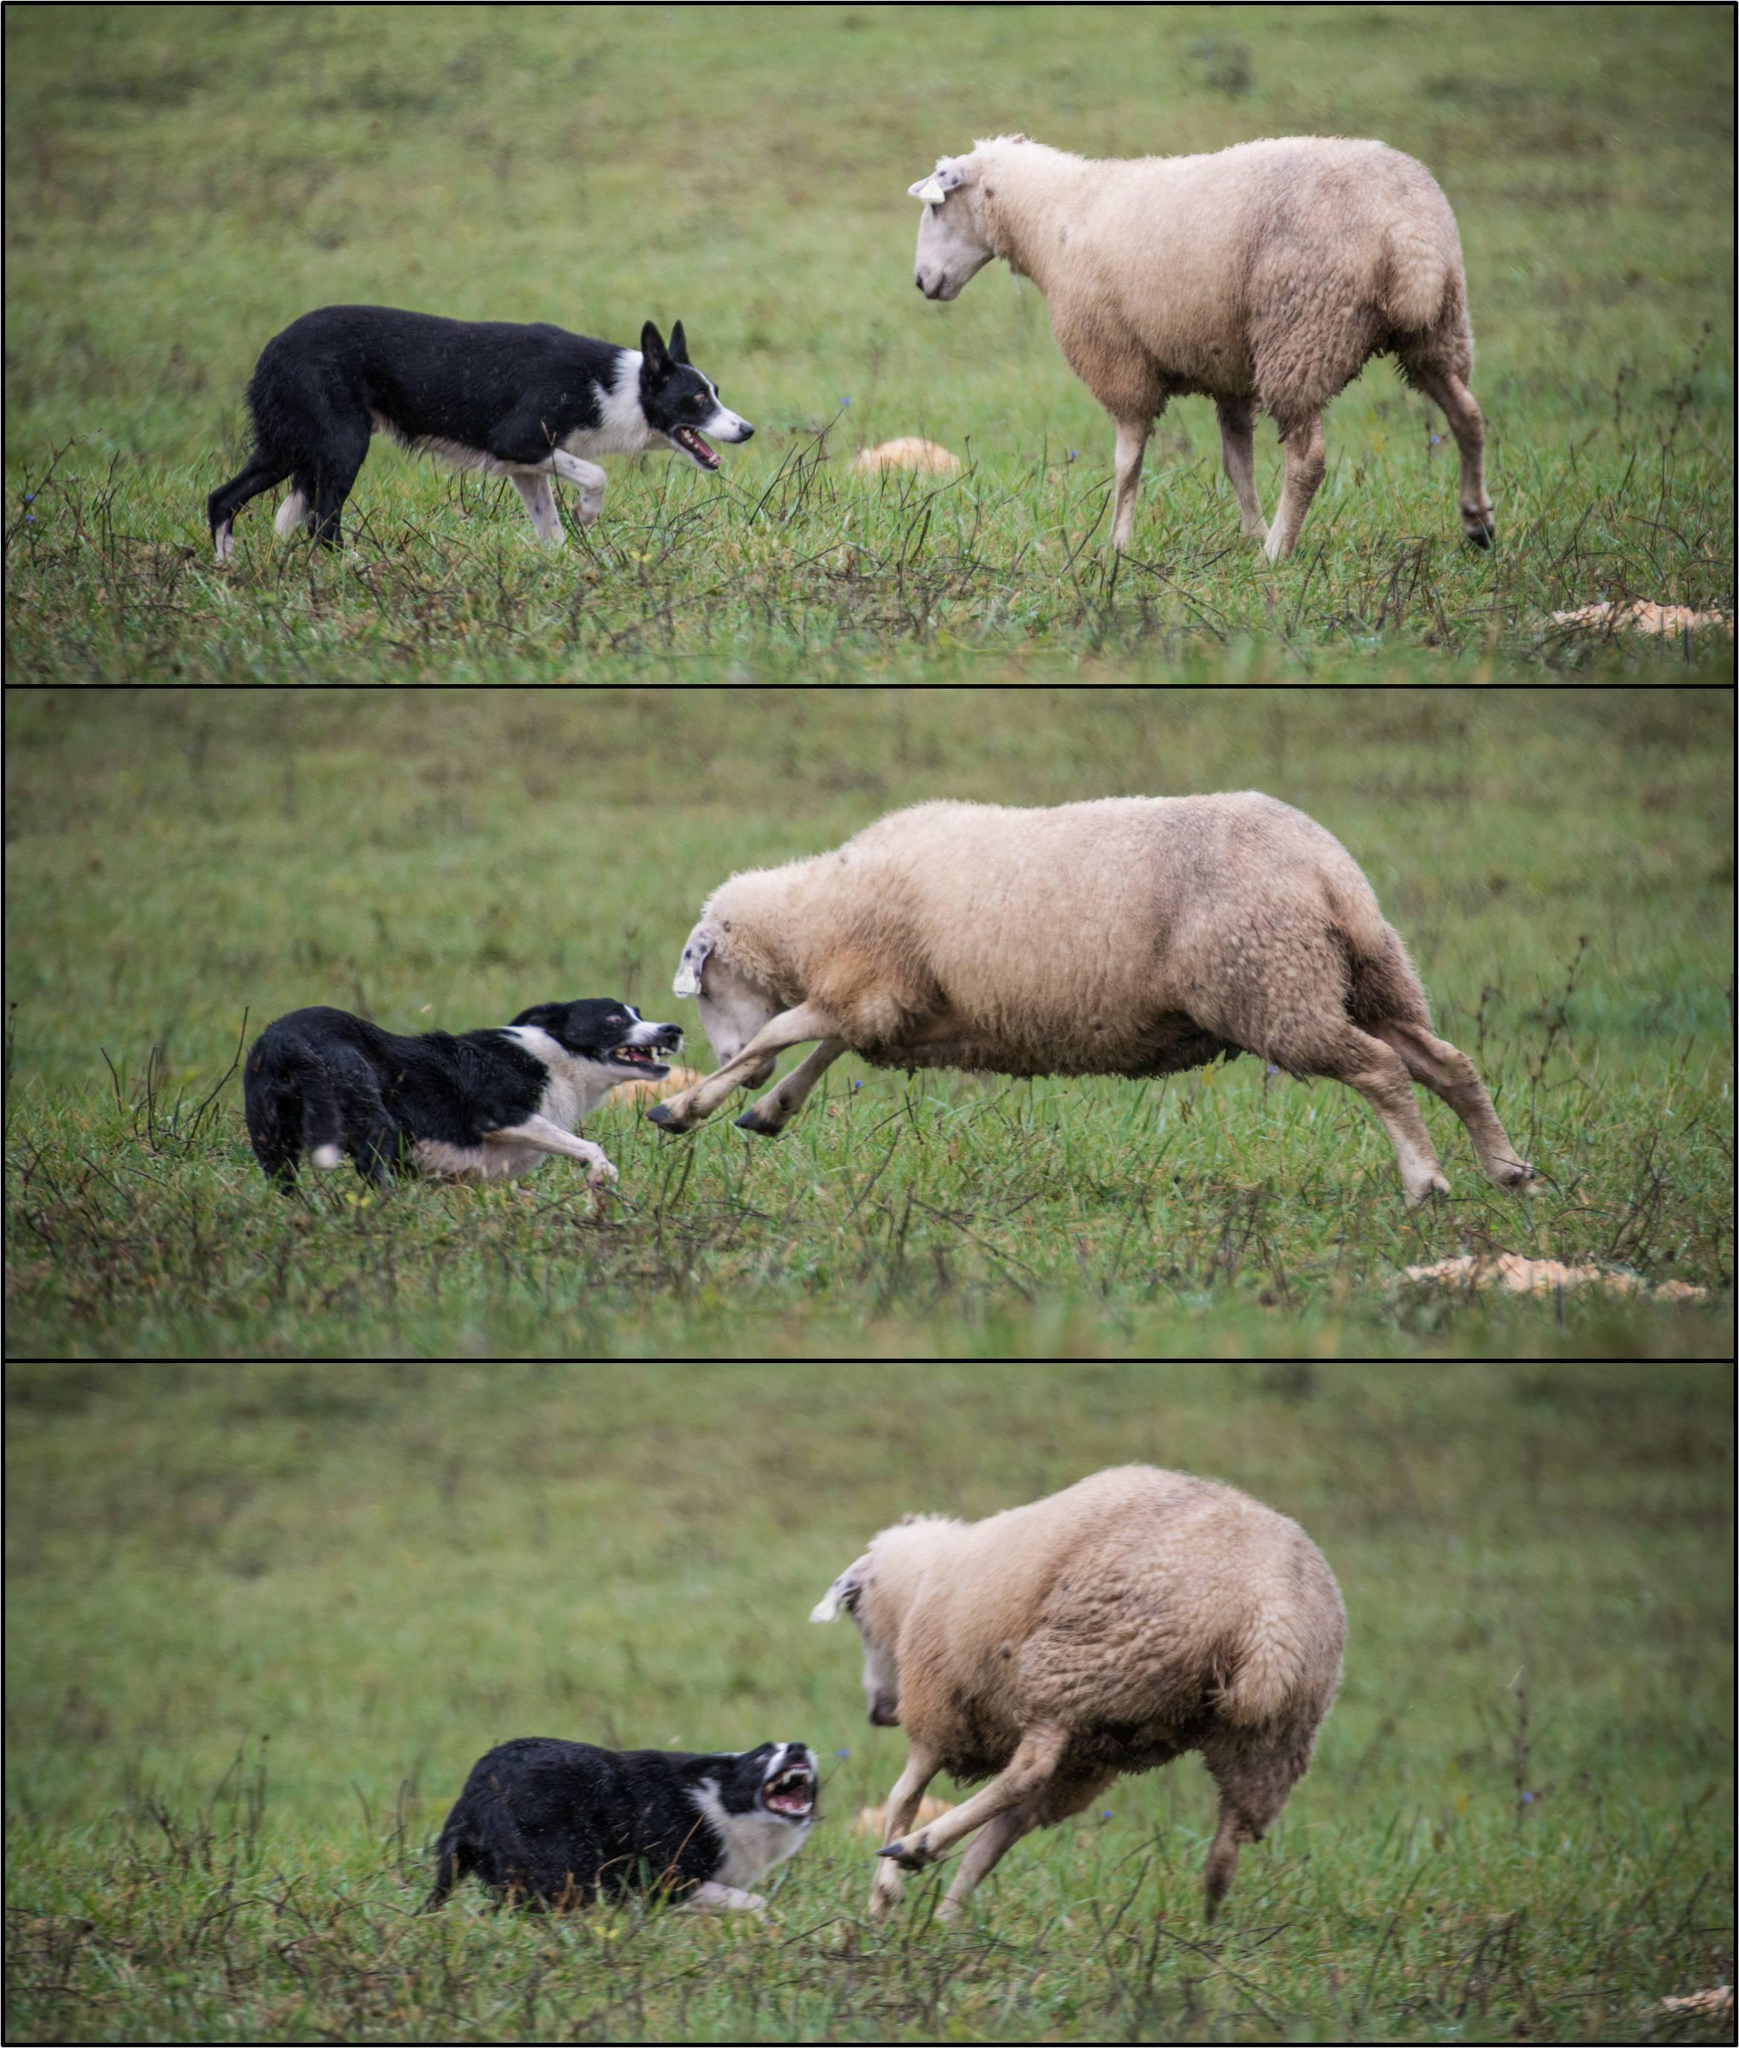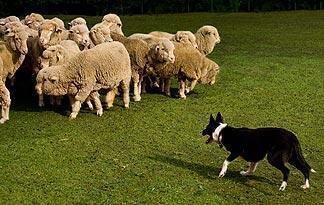The first image is the image on the left, the second image is the image on the right. For the images shown, is this caption "One image has exactly three dogs." true? Answer yes or no. Yes. 